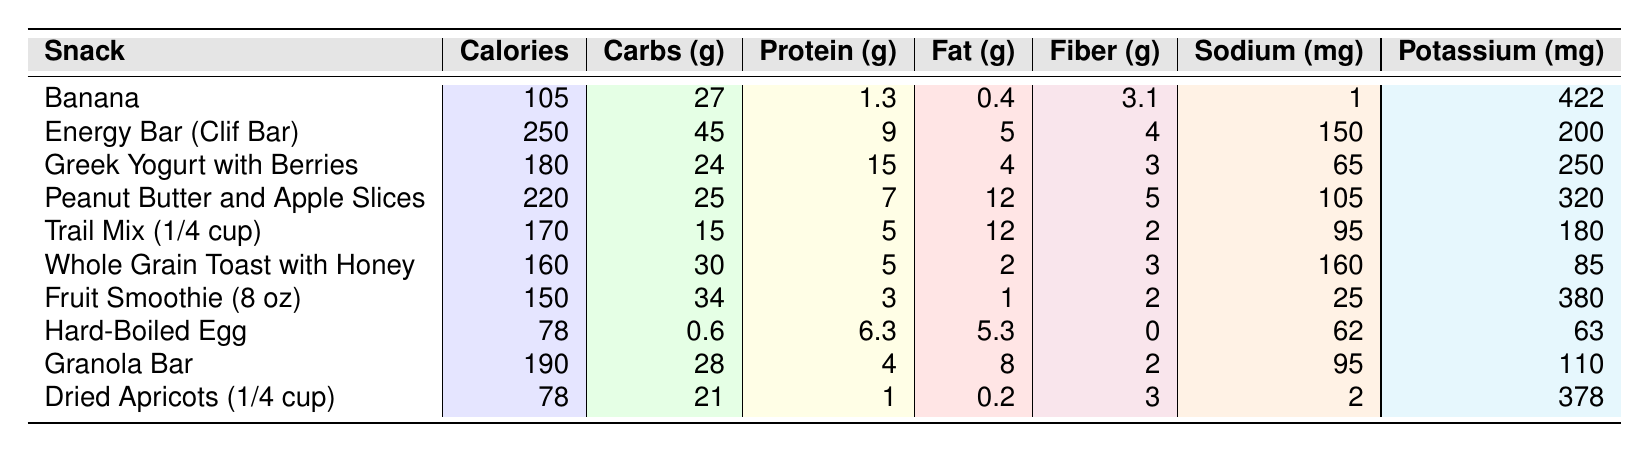What is the calorie content of a banana? In the table, the banana's calorie content is listed under the "Calories" column. It shows 105 calories for the banana.
Answer: 105 Which snack has the highest protein content? By comparing the "Protein (g)" values in the table, Greek Yogurt with Berries has the highest protein content at 15 grams.
Answer: Greek Yogurt with Berries What is the total carbohydrate content of the Energy Bar and Trail Mix? The carbohydrate content for the Energy Bar is 45 grams and for Trail Mix is 15 grams. Adding these two values, 45 + 15 = 60 grams total carbohydrates.
Answer: 60 grams Does the Whole Grain Toast with Honey have more sodium than the Peanut Butter and Apple Slices? The sodium content of Whole Grain Toast is 160 mg and for Peanut Butter and Apple Slices is 105 mg. Since 160 mg is greater than 105 mg, the statement is true.
Answer: Yes What is the average fat content of the snacks listed in the table? To find the average fat content, we first sum the fat values: 0.4 + 5 + 4 + 12 + 12 + 2 + 1 + 5.3 + 8 + 0.2 = 45.1 grams. There are 10 snacks, so we divide 45.1 by 10, giving an average of 4.51 grams.
Answer: 4.51 grams Which snack has the lowest calorie count? The snacks are compared based on the "Calories" column. The lowest calorie count is found in the Hard-Boiled Egg at 78 calories.
Answer: Hard-Boiled Egg How many snacks contain more than 200 calories? By examining the "Calories" column, the snacks with more than 200 calories are the Energy Bar (250 calories) and Peanut Butter and Apple Slices (220 calories). This gives us a total of 2 snacks.
Answer: 2 snacks Is the potassium content in Greek Yogurt higher than that in Dried Apricots? The potassium for Greek Yogurt is 250 mg and for Dried Apricots it's 378 mg. Since 250 mg is less than 378 mg, the statement is false.
Answer: No What is the difference in fiber content between the Peanut Butter and Apple Slices and Trail Mix? The fiber content for Peanut Butter and Apple Slices is 5 grams and for Trail Mix is 2 grams. To find the difference, subtract: 5 - 2 = 3 grams.
Answer: 3 grams Which snack contains the least amount of carbohydrates? The "Carbs (g)" column shows the lowest carbohydrate content is in the Hard-Boiled Egg with 0.6 grams.
Answer: Hard-Boiled Egg 